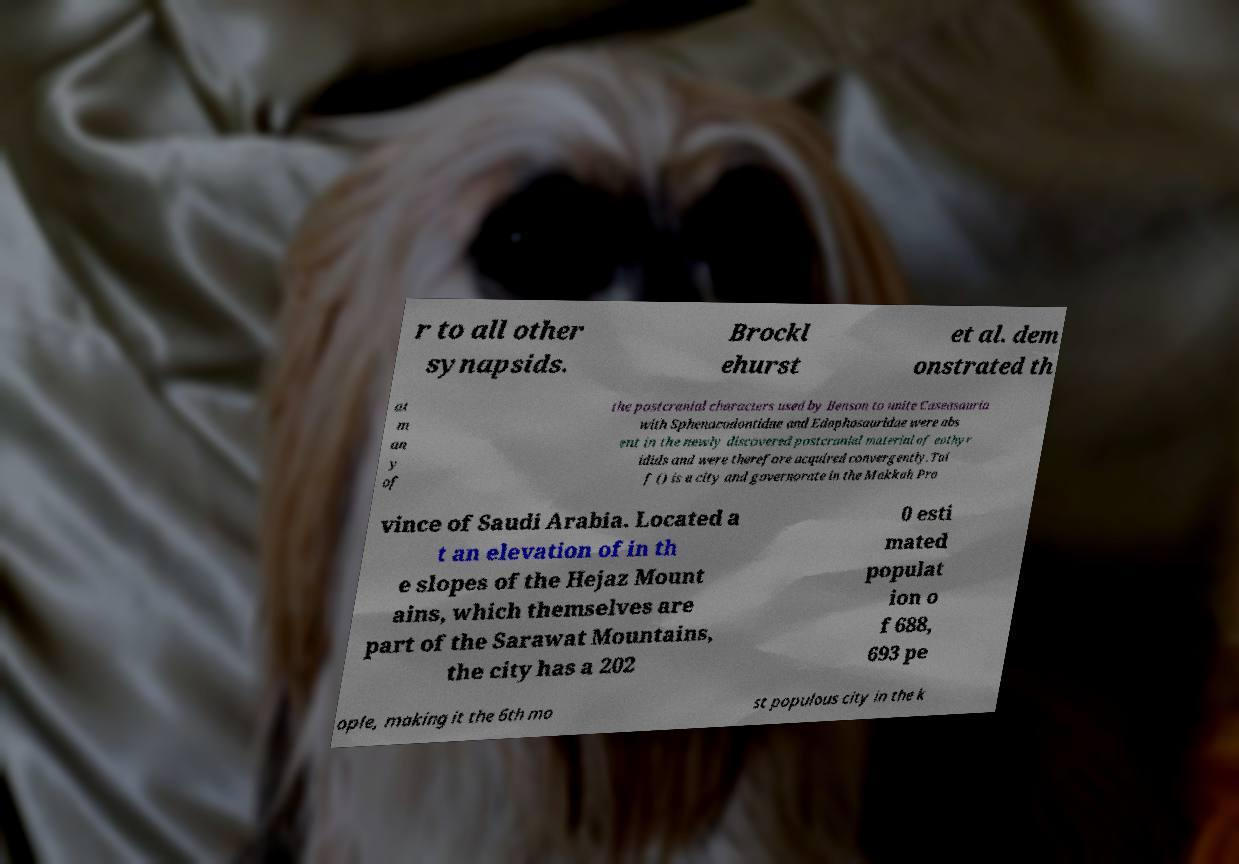Could you assist in decoding the text presented in this image and type it out clearly? r to all other synapsids. Brockl ehurst et al. dem onstrated th at m an y of the postcranial characters used by Benson to unite Caseasauria with Sphenacodontidae and Edaphosauridae were abs ent in the newly discovered postcranial material of eothyr idids and were therefore acquired convergently.Tai f () is a city and governorate in the Makkah Pro vince of Saudi Arabia. Located a t an elevation of in th e slopes of the Hejaz Mount ains, which themselves are part of the Sarawat Mountains, the city has a 202 0 esti mated populat ion o f 688, 693 pe ople, making it the 6th mo st populous city in the k 